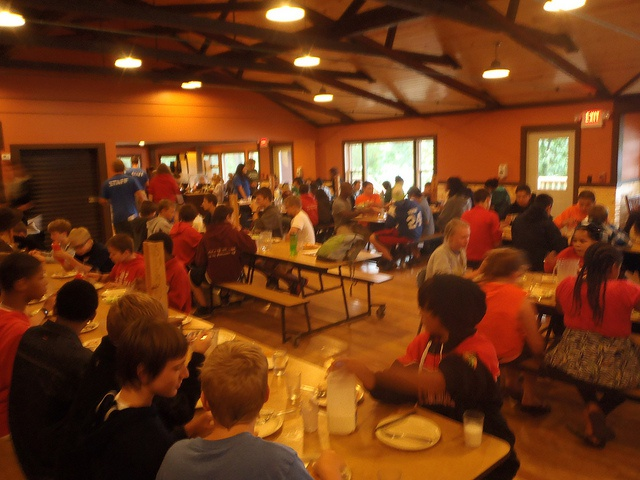Describe the objects in this image and their specific colors. I can see people in maroon, black, and brown tones, dining table in maroon, red, and orange tones, people in maroon, black, and brown tones, people in maroon, black, and brown tones, and people in maroon, brown, and black tones in this image. 